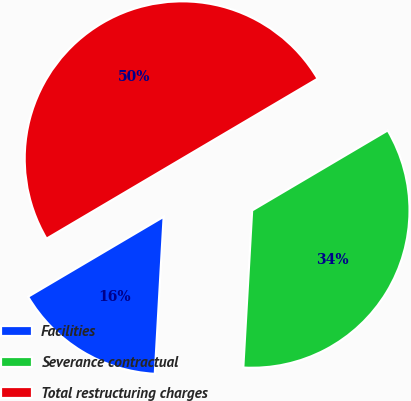<chart> <loc_0><loc_0><loc_500><loc_500><pie_chart><fcel>Facilities<fcel>Severance contractual<fcel>Total restructuring charges<nl><fcel>15.62%<fcel>34.38%<fcel>50.0%<nl></chart> 